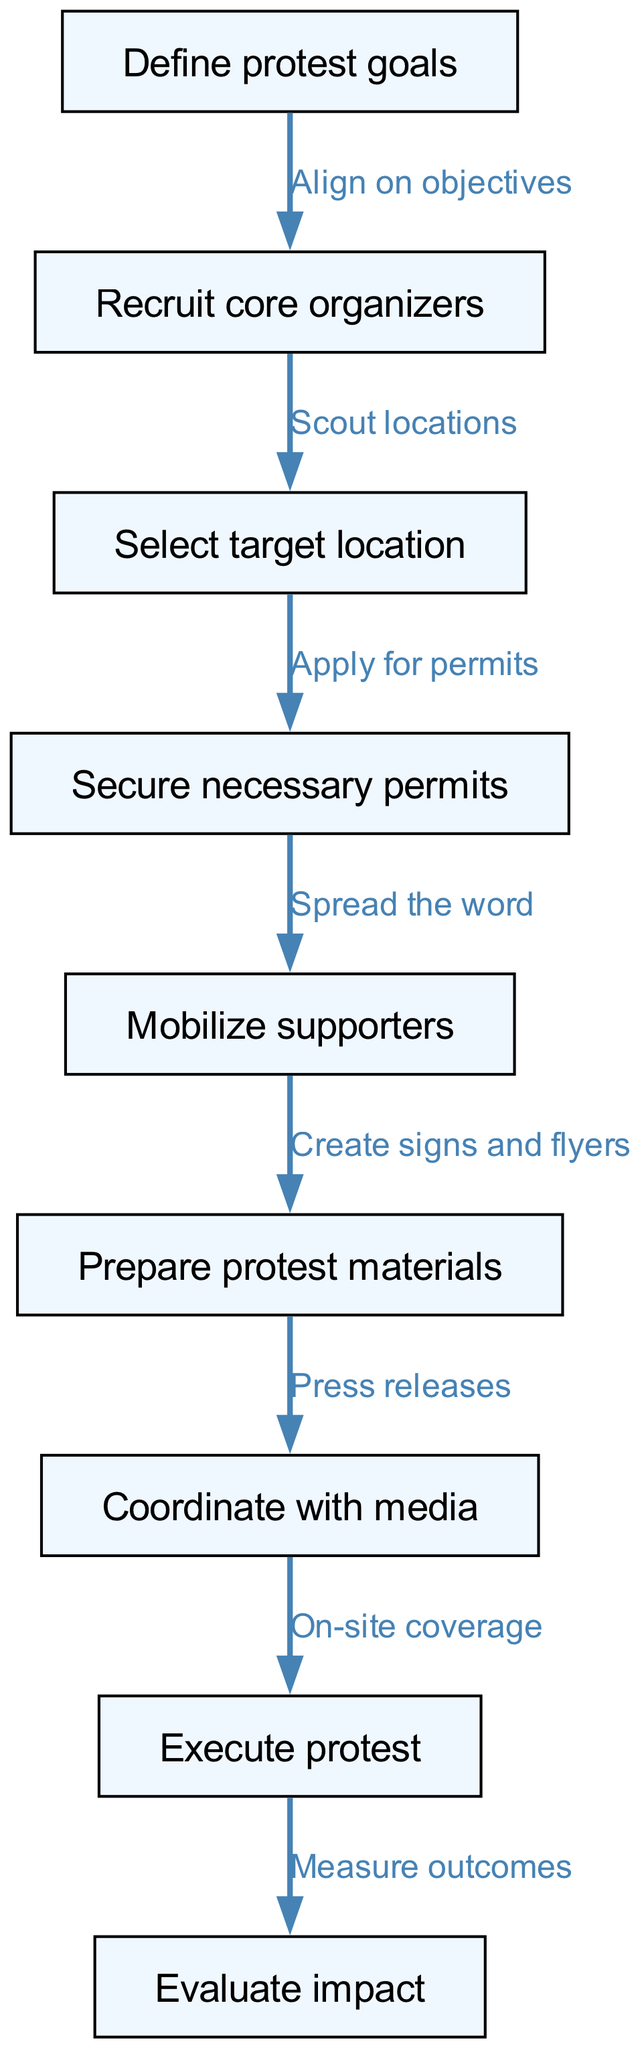What is the first step in the protest organization process? The first node in the diagram is "Define protest goals," indicating that this is the initial step in organizing a protest.
Answer: Define protest goals How many nodes are present in the diagram? By counting the nodes listed, we find there are nine distinct steps depicted in the diagram.
Answer: 9 What is the label of the last node in the process flow? The last node in the diagram is "Evaluate impact," which is the final step in the organization process.
Answer: Evaluate impact Which node comes after securing necessary permits? The diagram shows that after "Secure necessary permits," the next step is "Mobilize supporters."
Answer: Mobilize supporters What is the relationship between recruiting core organizers and selecting target location? The edge connecting these two nodes is labeled "Scout locations," signifying the next action following recruitment.
Answer: Scout locations What step follows preparing protest materials? Based on the flow in the diagram, "Prepare protest materials" leads to "Coordinate with media" as the subsequent action.
Answer: Coordinate with media What is the function of the media coordination step? The edge from "Coordinate with media" to "Execute protest" is labeled "On-site coverage," showing the media's role in the execution process.
Answer: On-site coverage How does the protest event culminate in assessing its impact? The diagram flows from "Execute protest" to "Evaluate impact," indicating that the execution of the protest leads directly to evaluating its outcomes.
Answer: Measure outcomes How are the objectives of the protest aligned? "Align on objectives" is the label of the edge connecting "Define protest goals" to "Recruit core organizers," showing this hierarchical relationship.
Answer: Align on objectives 